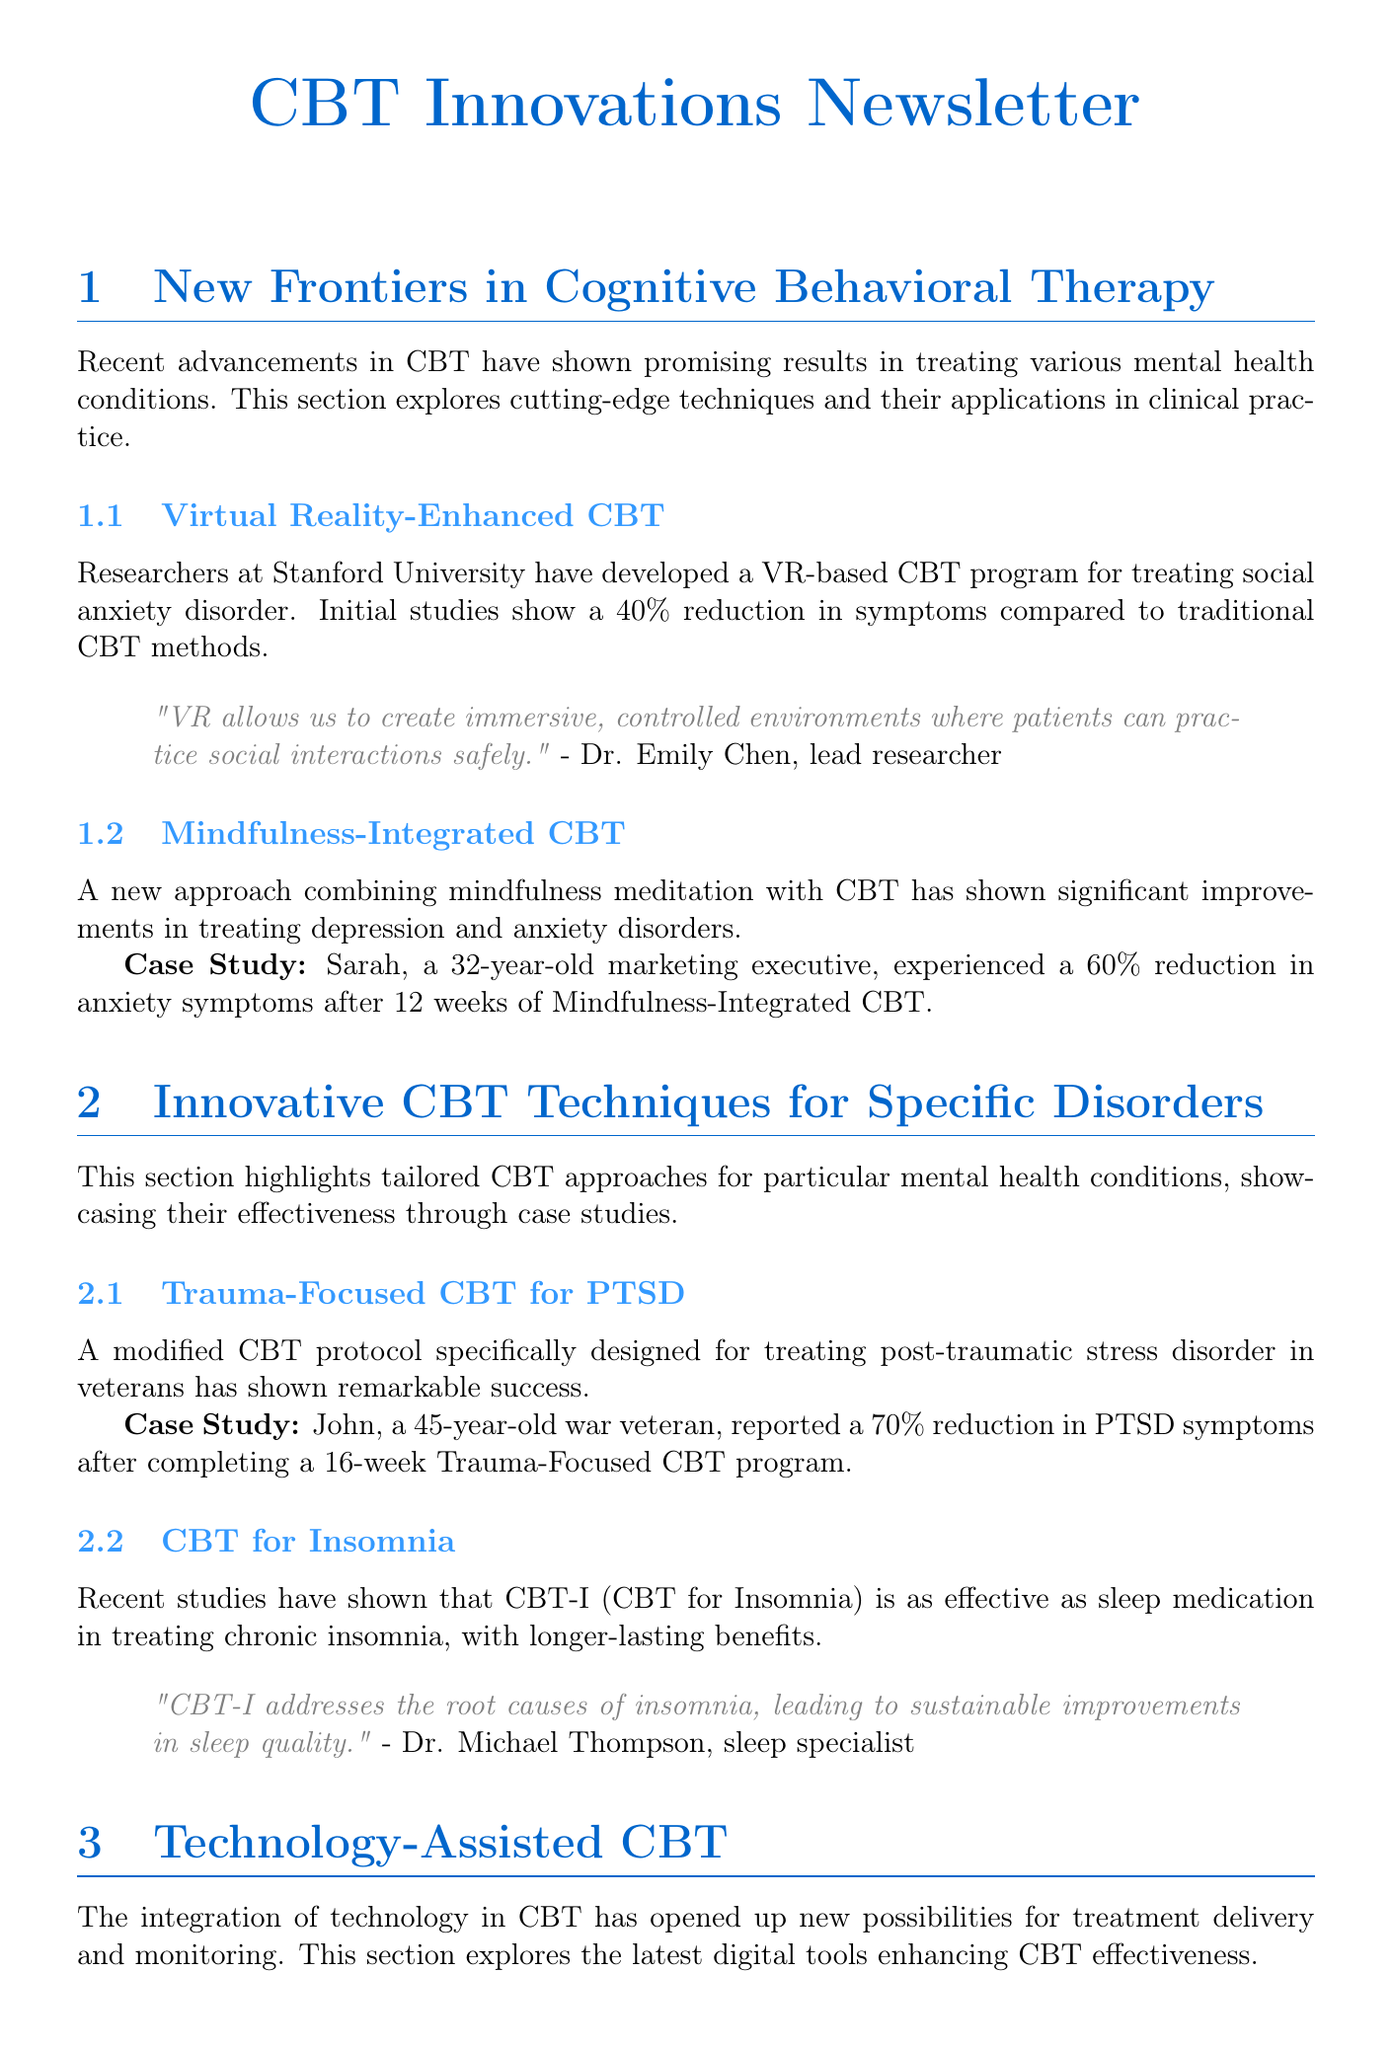what is the reduction in symptoms from the VR-based CBT program? The document states that initial studies show a 40% reduction in symptoms compared to traditional CBT methods.
Answer: 40% who developed the VR-based CBT program? The document mentions that researchers at Stanford University developed the VR-based CBT program.
Answer: Stanford University what percentage reduction in anxiety symptoms did Sarah experience? Sarah, after 12 weeks of Mindfulness-Integrated CBT, experienced a 60% reduction in anxiety symptoms.
Answer: 60% what was the reduction percentage of PTSD symptoms for John after Trauma-Focused CBT? John reported a 70% reduction in PTSD symptoms after completing a 16-week program.
Answer: 70% what form of technology is used to monitor physiological responses during CBT? The document references wearable technology like smartwatches and fitness trackers for monitoring.
Answer: wearable technology what is the main benefit of AI-powered CBT apps according to Dr. Sophia Rodriguez? According to Dr. Sophia Rodriguez, AI-powered CBT apps can provide 24/7 support and real-time interventions.
Answer: 24/7 support what was the percentage decrease in workplace stress levels after Google implemented the CBT-based stress management program? The document states there was a 30% decrease in reported workplace stress levels among participants.
Answer: 30% which specific disorder was targeted by the modified CBT protocol for veterans? The modified CBT protocol was specifically designed for treating post-traumatic stress disorder (PTSD).
Answer: PTSD what does the integration of technology in CBT open up new possibilities for? The document suggests that it opens up new possibilities for treatment delivery and monitoring.
Answer: treatment delivery and monitoring 